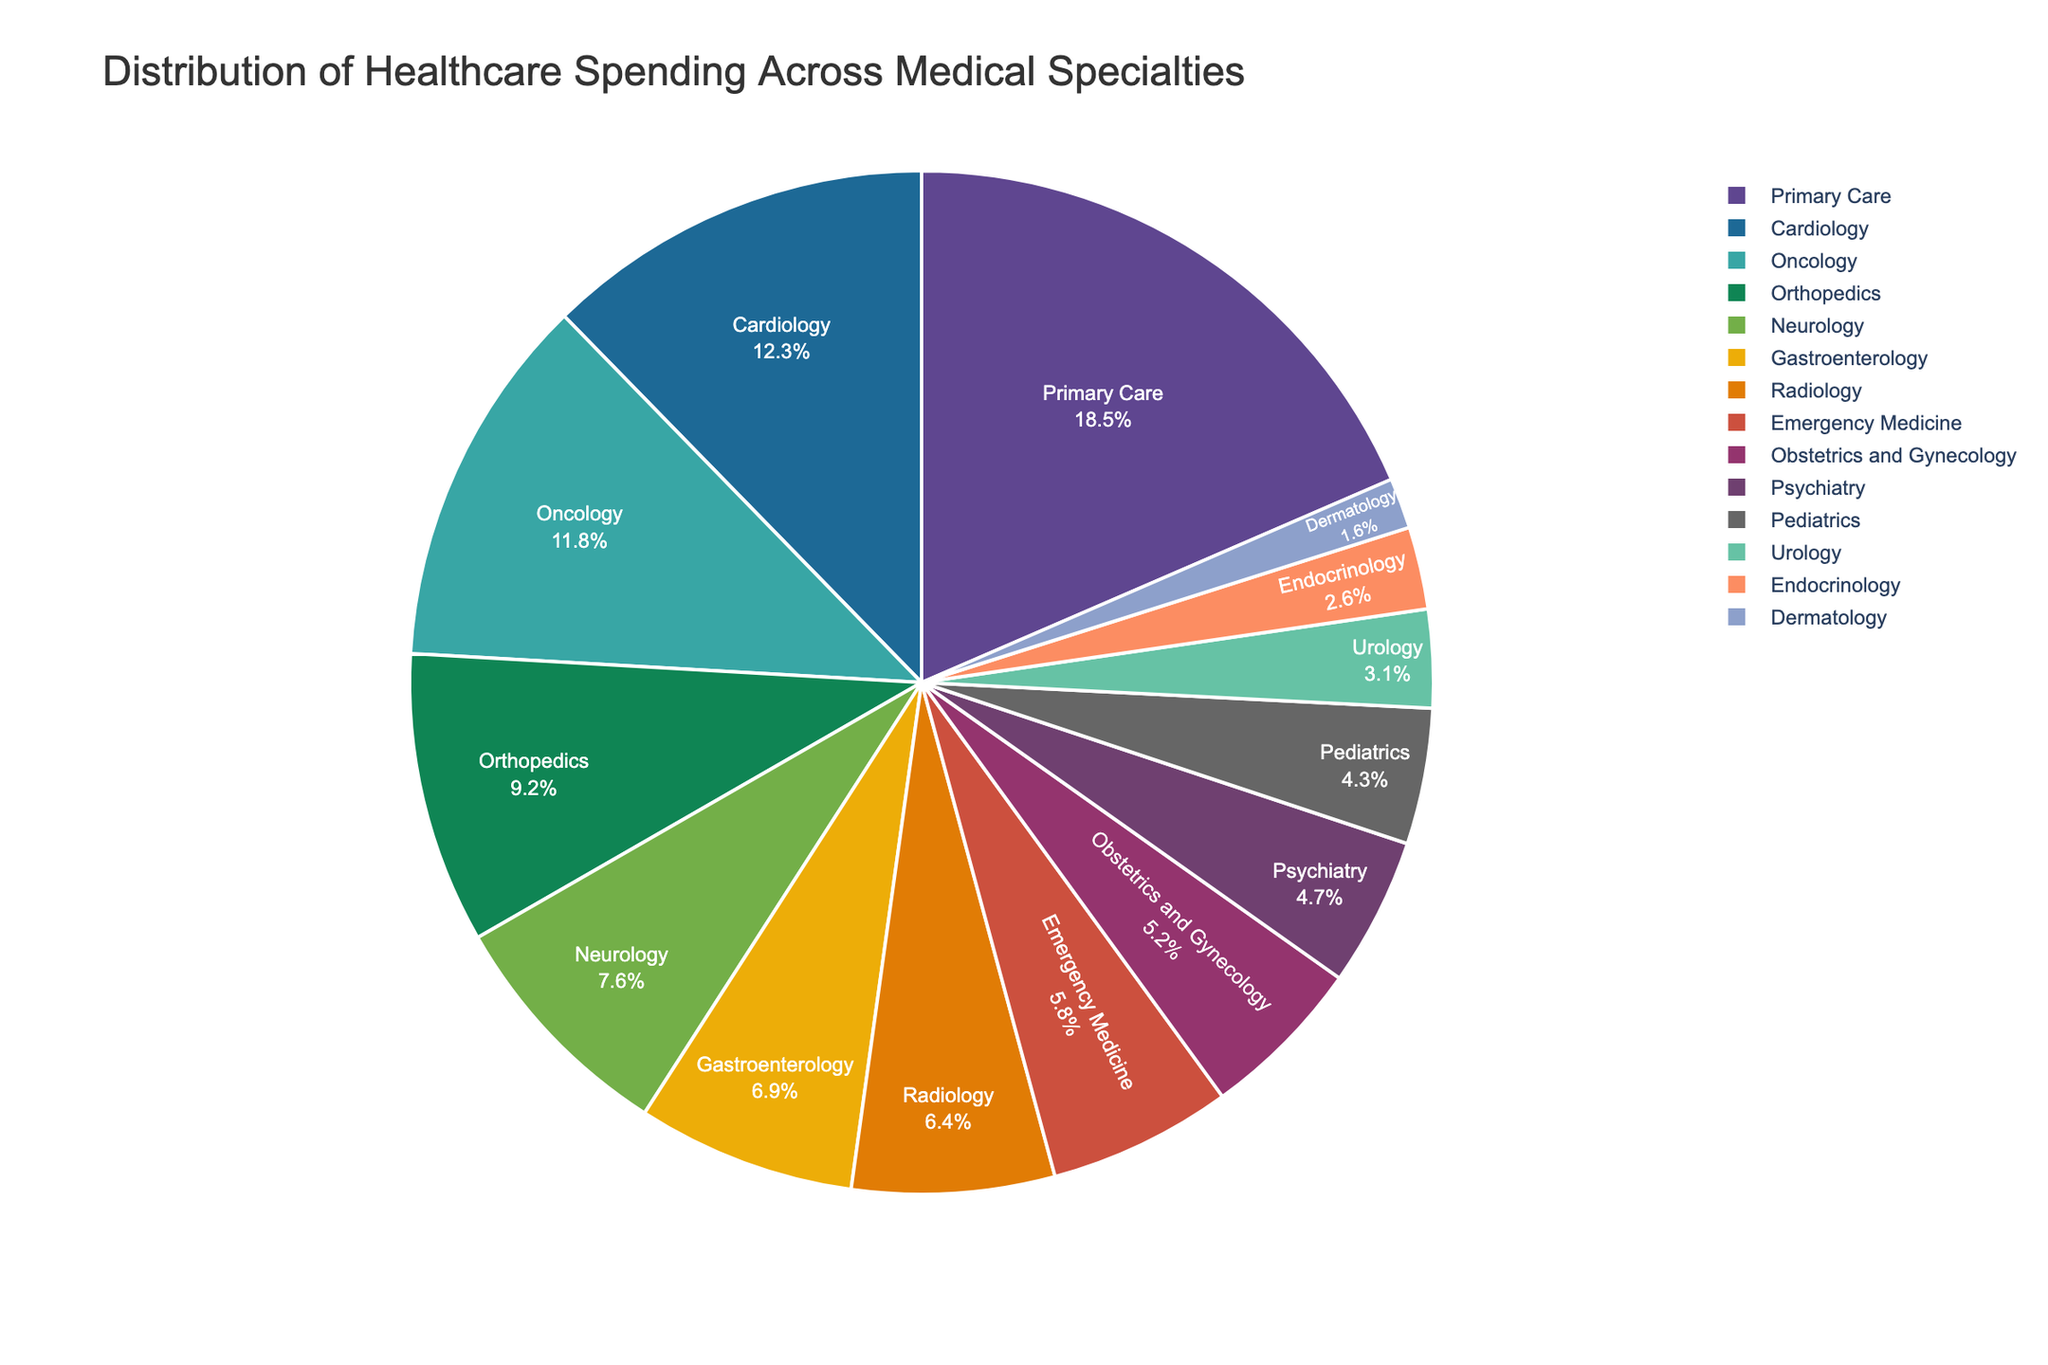Which medical specialty has the highest percentage of healthcare spending? To determine the specialty with the highest percentage, look at the labels and percentages on the pie chart and find the highest value. In this case, Primary Care has the highest percentage at 18.5%.
Answer: Primary Care Which specialties have a combined spending percentage of more than 30%? Add the percentages of various specialties until the sum exceeds 30%. Primary Care (18.5%) and Cardiology (12.3%) together sum to 30.8%, which is more than 30%.
Answer: Primary Care and Cardiology What percentage of healthcare spending is allocated to Emergency Medicine and Pediatrics combined? Sum the percentages of Emergency Medicine (5.8%) and Pediatrics (4.3%). 5.8% + 4.3% = 10.1%.
Answer: 10.1% How does the spending on Neurology compare to that on Gastroenterology? Compare the percentages directly. Neurology is 7.6% and Gastroenterology is 6.9%. Neurology's percentage is higher.
Answer: Neurology Which specialty has the lowest percentage of healthcare spending? Look for the smallest percentage on the pie chart. Dermatology has the lowest at 1.6%.
Answer: Dermatology Is the spending on Orthopedics greater than combined spending on Urology and Endocrinology? Compare Orthopedics (9.2%) with the combined spending on Urology (3.1%) and Endocrinology (2.6%). 3.1% + 2.6% = 5.7%, which is less than 9.2%.
Answer: Yes Which three specialties make up approximately 30% of the spending together? Find three specialties whose percentages add up to around 30%. Cardiology (12.3%), Oncology (11.8%), and Orthopedics (9.2%) sum to 33.3%, which is approximately 30%.
Answer: Cardiology, Oncology, and Orthopedics How much more is the spending on Radiology compared to Psychiatry? Subtract the Psychiatry percentage (4.7%) from Radiology's (6.4%). 6.4% - 4.7% = 1.7%.
Answer: 1.7% Which specialties have a spending percentage lower than 5%? Identify the specialties with less than 5% spending. Psychiatry (4.7%), Pediatrics (4.3%), Urology (3.1%), Endocrinology (2.6%), and Dermatology (1.6%) all fit this criteria.
Answer: Psychiatry, Pediatrics, Urology, Endocrinology, Dermatology 